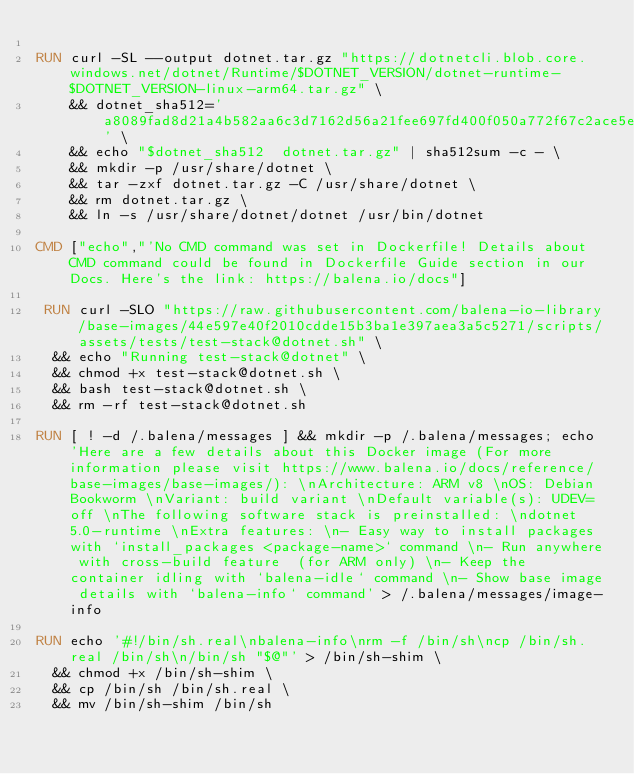Convert code to text. <code><loc_0><loc_0><loc_500><loc_500><_Dockerfile_>
RUN curl -SL --output dotnet.tar.gz "https://dotnetcli.blob.core.windows.net/dotnet/Runtime/$DOTNET_VERSION/dotnet-runtime-$DOTNET_VERSION-linux-arm64.tar.gz" \
    && dotnet_sha512='a8089fad8d21a4b582aa6c3d7162d56a21fee697fd400f050a772f67c2ace5e4196d1c4261d3e861d6dc2e5439666f112c406104d6271e5ab60cda80ef2ffc64' \
    && echo "$dotnet_sha512  dotnet.tar.gz" | sha512sum -c - \
    && mkdir -p /usr/share/dotnet \
    && tar -zxf dotnet.tar.gz -C /usr/share/dotnet \
    && rm dotnet.tar.gz \
    && ln -s /usr/share/dotnet/dotnet /usr/bin/dotnet

CMD ["echo","'No CMD command was set in Dockerfile! Details about CMD command could be found in Dockerfile Guide section in our Docs. Here's the link: https://balena.io/docs"]

 RUN curl -SLO "https://raw.githubusercontent.com/balena-io-library/base-images/44e597e40f2010cdde15b3ba1e397aea3a5c5271/scripts/assets/tests/test-stack@dotnet.sh" \
  && echo "Running test-stack@dotnet" \
  && chmod +x test-stack@dotnet.sh \
  && bash test-stack@dotnet.sh \
  && rm -rf test-stack@dotnet.sh 

RUN [ ! -d /.balena/messages ] && mkdir -p /.balena/messages; echo 'Here are a few details about this Docker image (For more information please visit https://www.balena.io/docs/reference/base-images/base-images/): \nArchitecture: ARM v8 \nOS: Debian Bookworm \nVariant: build variant \nDefault variable(s): UDEV=off \nThe following software stack is preinstalled: \ndotnet 5.0-runtime \nExtra features: \n- Easy way to install packages with `install_packages <package-name>` command \n- Run anywhere with cross-build feature  (for ARM only) \n- Keep the container idling with `balena-idle` command \n- Show base image details with `balena-info` command' > /.balena/messages/image-info

RUN echo '#!/bin/sh.real\nbalena-info\nrm -f /bin/sh\ncp /bin/sh.real /bin/sh\n/bin/sh "$@"' > /bin/sh-shim \
	&& chmod +x /bin/sh-shim \
	&& cp /bin/sh /bin/sh.real \
	&& mv /bin/sh-shim /bin/sh</code> 